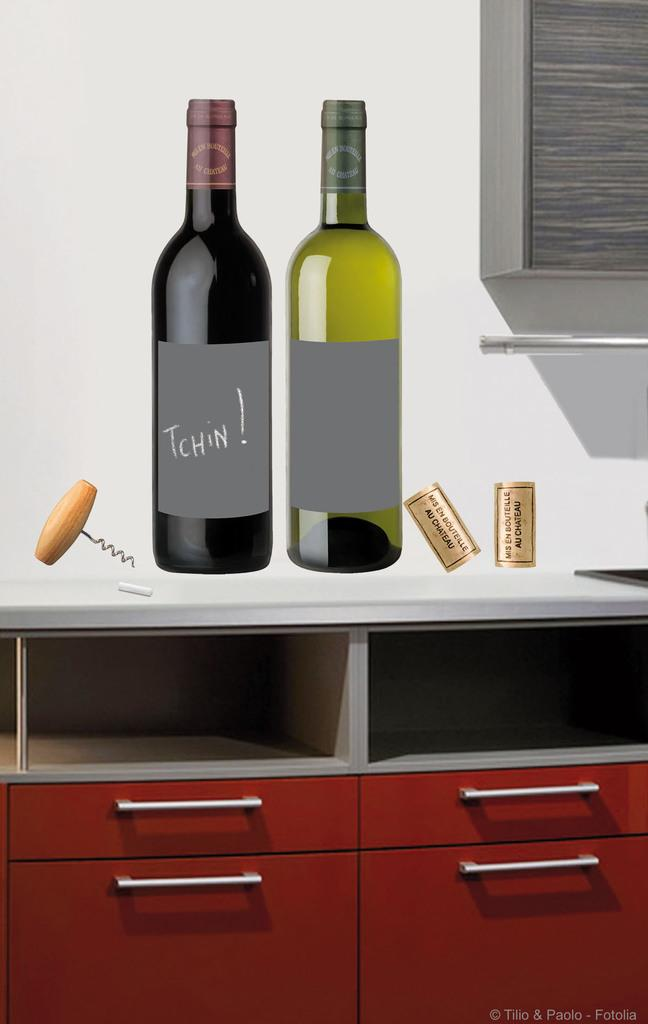How many bottles are on the table in the image? There are two bottles on the table in the image. What else can be seen in the image besides the bottles? There are stickers and racks visible in the image. What type of object are the racks? The racks are objects used for storage or display. Can you describe the overall appearance of the image? The image appears to be a graphic representation. What type of creature is interacting with the zipper in the image? There is no zipper or creature present in the image. 